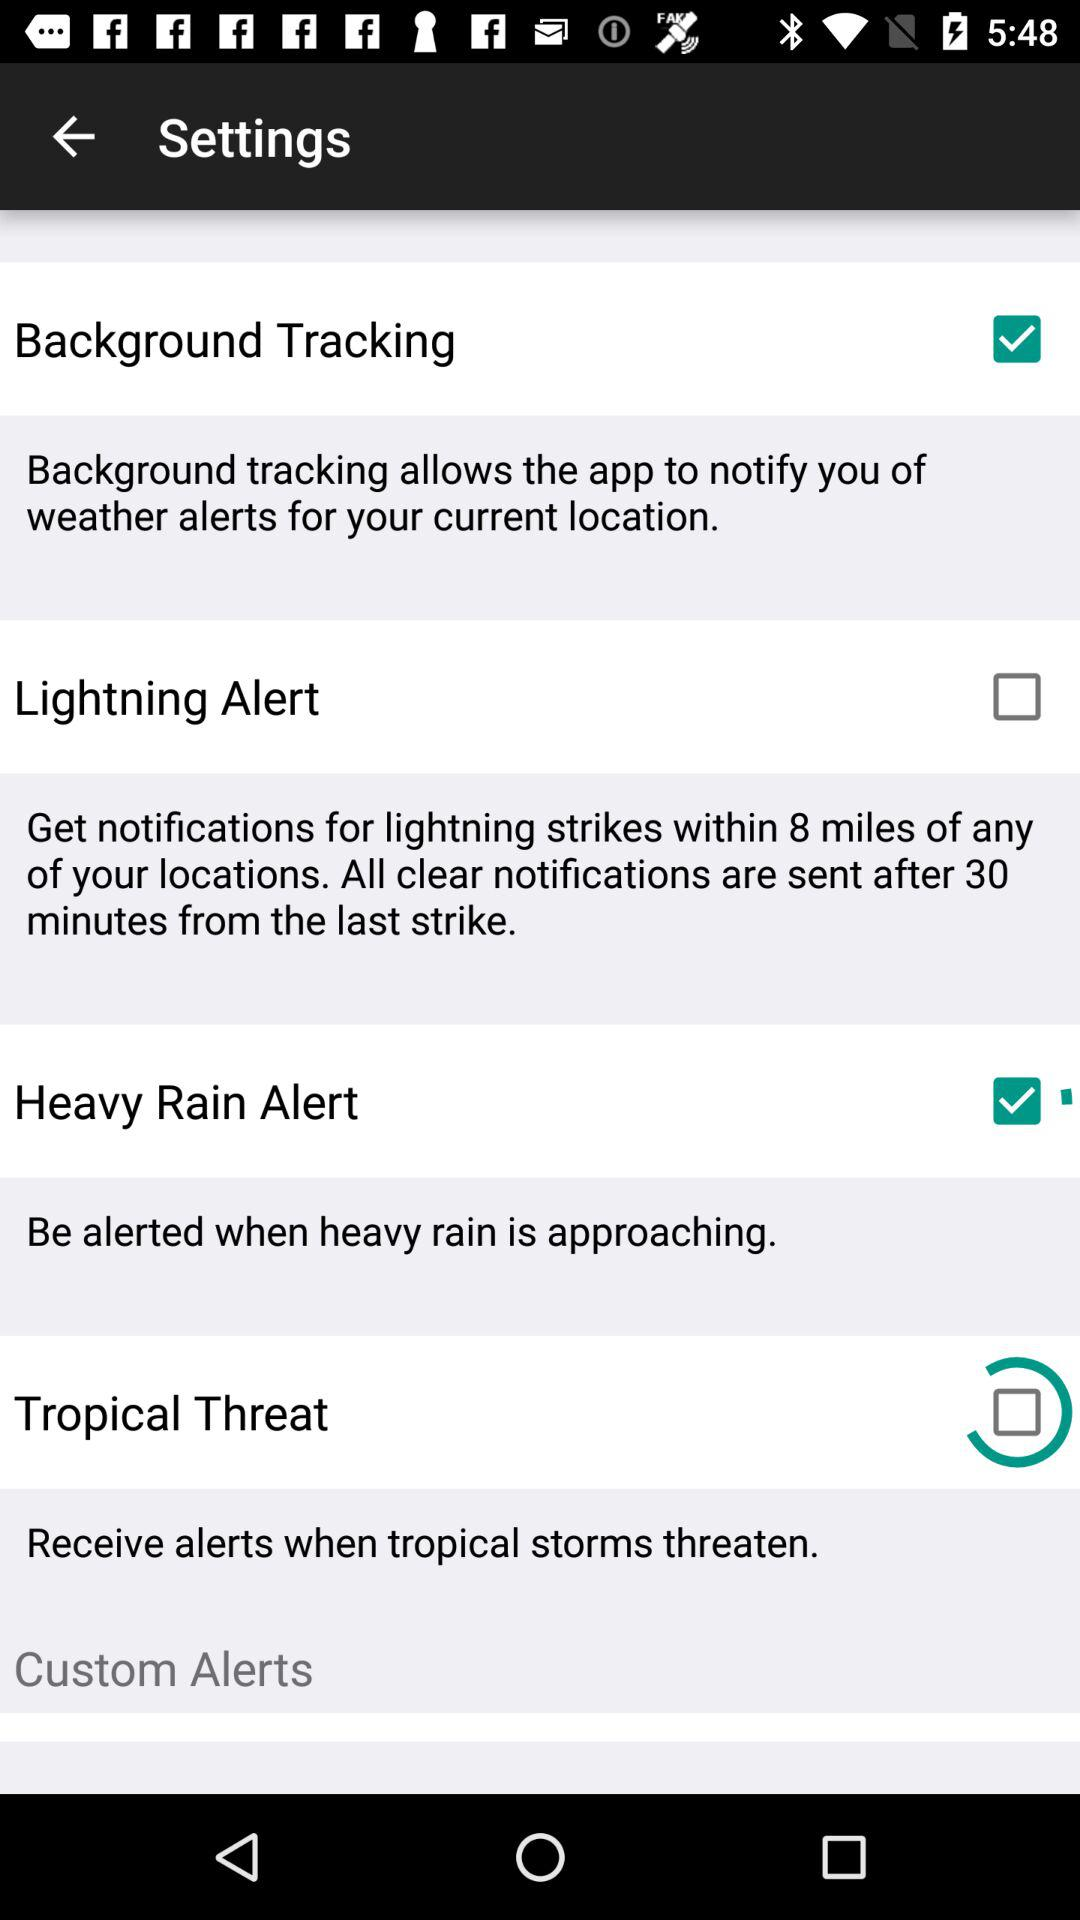When will the clear notification be sent from the last strike? The clear notification will be sent 30 minutes after the last strike. 